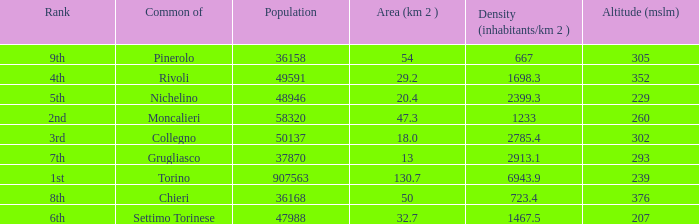How many altitudes does the common with an area of 130.7 km^2 have? 1.0. 